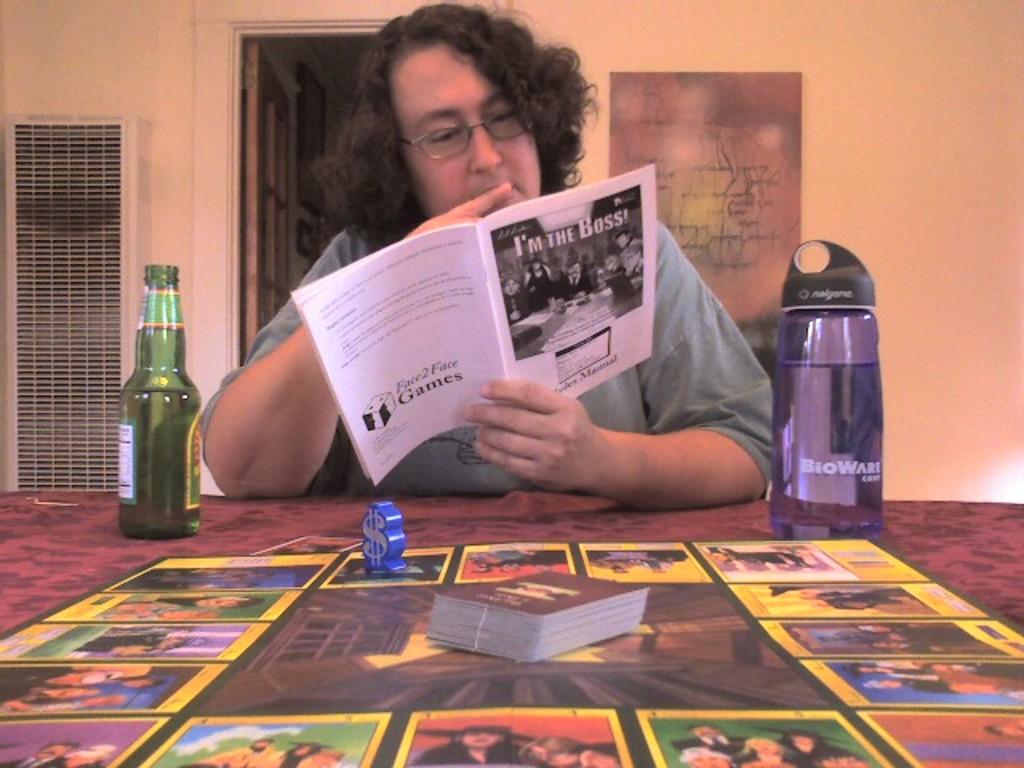What is the name of the game that the person is reading instructions for?
Provide a succinct answer. I'm the boss. What game is she playing?
Your answer should be very brief. I'm the boss. 